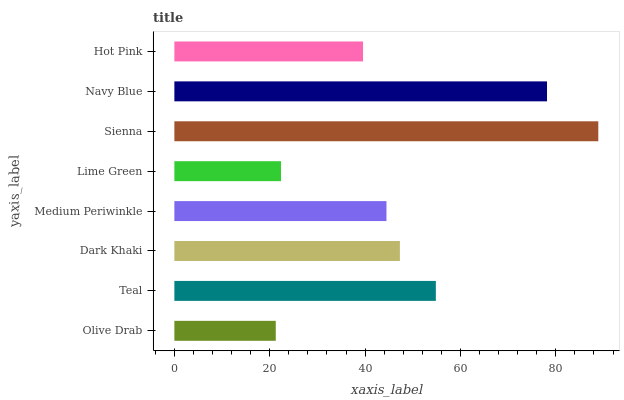Is Olive Drab the minimum?
Answer yes or no. Yes. Is Sienna the maximum?
Answer yes or no. Yes. Is Teal the minimum?
Answer yes or no. No. Is Teal the maximum?
Answer yes or no. No. Is Teal greater than Olive Drab?
Answer yes or no. Yes. Is Olive Drab less than Teal?
Answer yes or no. Yes. Is Olive Drab greater than Teal?
Answer yes or no. No. Is Teal less than Olive Drab?
Answer yes or no. No. Is Dark Khaki the high median?
Answer yes or no. Yes. Is Medium Periwinkle the low median?
Answer yes or no. Yes. Is Olive Drab the high median?
Answer yes or no. No. Is Dark Khaki the low median?
Answer yes or no. No. 